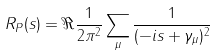Convert formula to latex. <formula><loc_0><loc_0><loc_500><loc_500>R _ { P } ( s ) = \Re \frac { 1 } { 2 \pi ^ { 2 } } \sum _ { \mu } \frac { 1 } { ( - i s + \gamma _ { \mu } ) ^ { 2 } }</formula> 